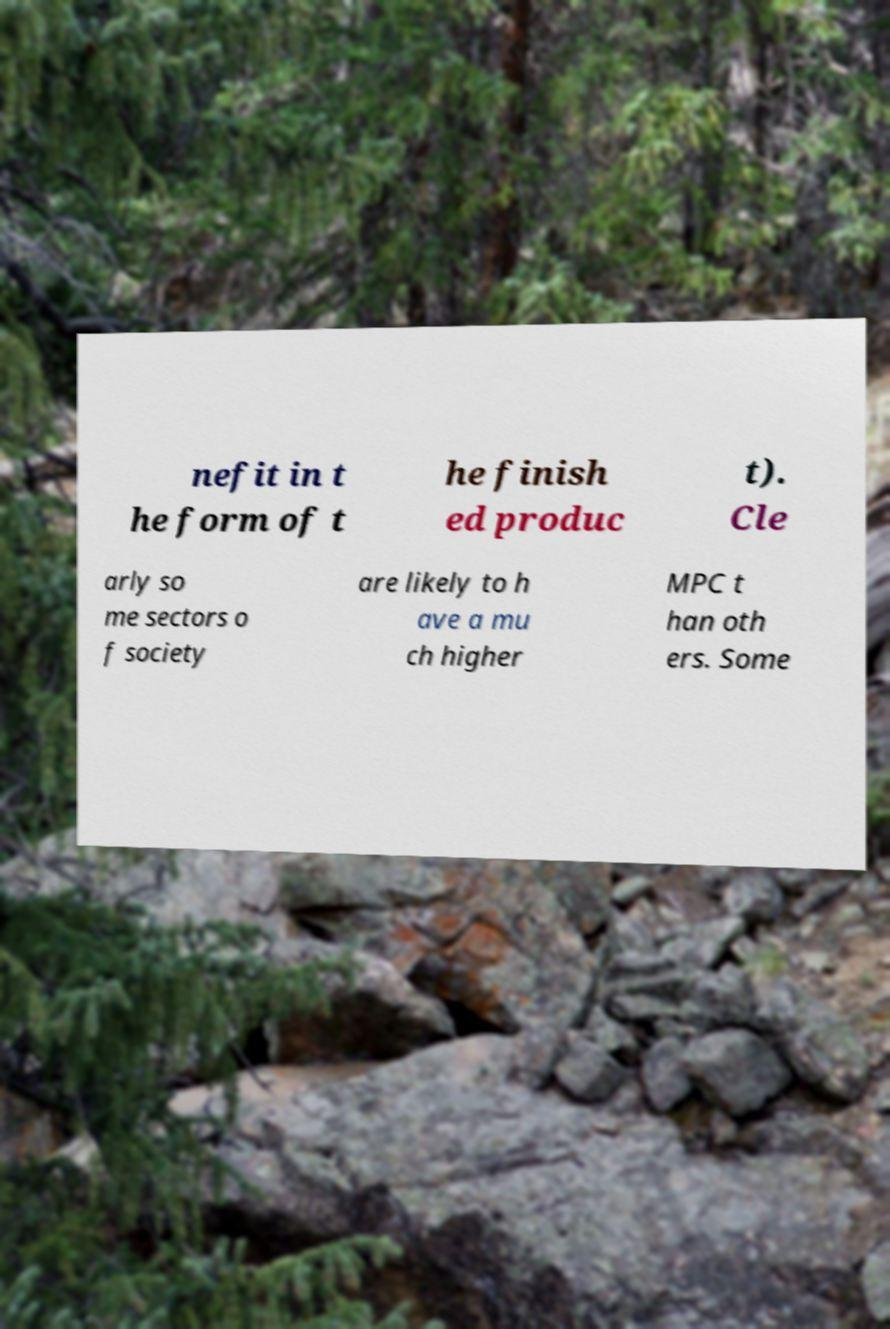Please read and relay the text visible in this image. What does it say? nefit in t he form of t he finish ed produc t). Cle arly so me sectors o f society are likely to h ave a mu ch higher MPC t han oth ers. Some 